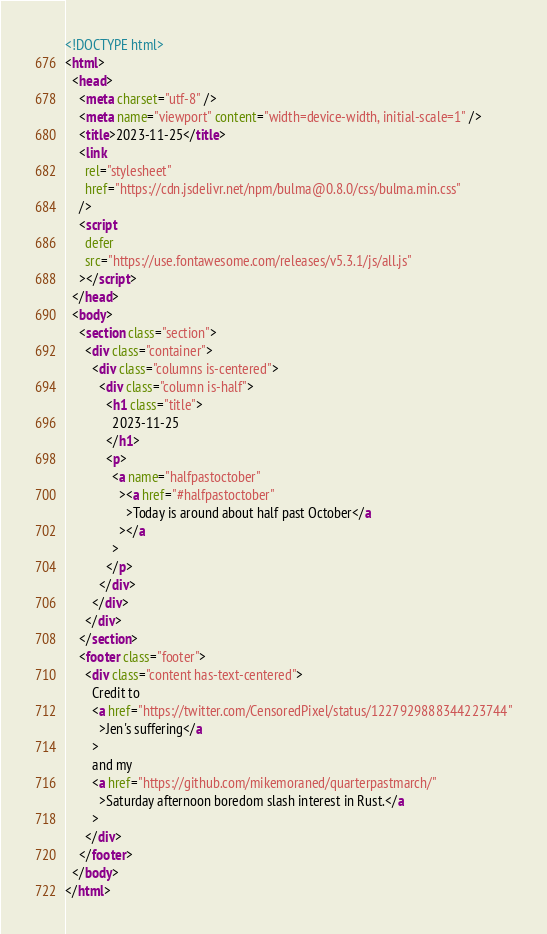<code> <loc_0><loc_0><loc_500><loc_500><_HTML_><!DOCTYPE html>
<html>
  <head>
    <meta charset="utf-8" />
    <meta name="viewport" content="width=device-width, initial-scale=1" />
    <title>2023-11-25</title>
    <link
      rel="stylesheet"
      href="https://cdn.jsdelivr.net/npm/bulma@0.8.0/css/bulma.min.css"
    />
    <script
      defer
      src="https://use.fontawesome.com/releases/v5.3.1/js/all.js"
    ></script>
  </head>
  <body>
    <section class="section">
      <div class="container">
        <div class="columns is-centered">
          <div class="column is-half">
            <h1 class="title">
              2023-11-25
            </h1>
            <p>
              <a name="halfpastoctober"
                ><a href="#halfpastoctober"
                  >Today is around about half past October</a
                ></a
              >
            </p>
          </div>
        </div>
      </div>
    </section>
    <footer class="footer">
      <div class="content has-text-centered">
        Credit to
        <a href="https://twitter.com/CensoredPixel/status/1227929888344223744"
          >Jen's suffering</a
        >
        and my
        <a href="https://github.com/mikemoraned/quarterpastmarch/"
          >Saturday afternoon boredom slash interest in Rust.</a
        >
      </div>
    </footer>
  </body>
</html></code> 